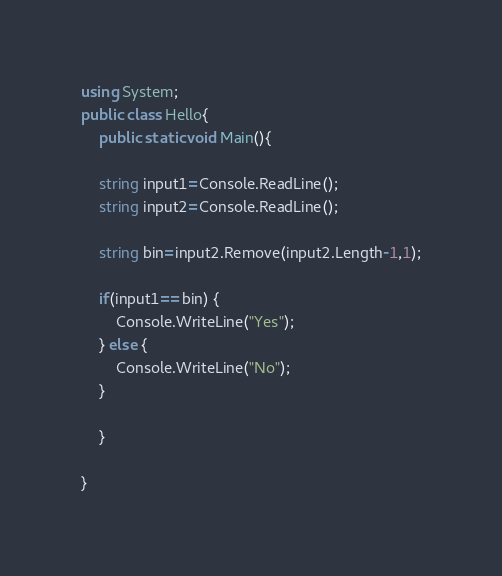<code> <loc_0><loc_0><loc_500><loc_500><_C#_>using System;
public class Hello{
    public static void Main(){

    string input1=Console.ReadLine();
    string input2=Console.ReadLine();
    
    string bin=input2.Remove(input2.Length-1,1);

    if(input1==bin) {
        Console.WriteLine("Yes");
    } else {
        Console.WriteLine("No");
    }

    }
    
}
</code> 